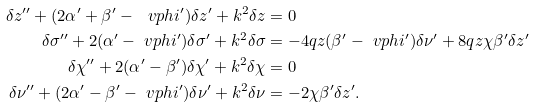Convert formula to latex. <formula><loc_0><loc_0><loc_500><loc_500>\delta z ^ { \prime \prime } + ( 2 \alpha ^ { \prime } + \beta ^ { \prime } - \ v p h i ^ { \prime } ) \delta z ^ { \prime } + k ^ { 2 } \delta z & = 0 \\ \delta \sigma ^ { \prime \prime } + 2 ( \alpha ^ { \prime } - \ v p h i ^ { \prime } ) \delta \sigma ^ { \prime } + k ^ { 2 } \delta \sigma & = - 4 q z ( \beta ^ { \prime } - \ v p h i ^ { \prime } ) \delta \nu ^ { \prime } + 8 q z \chi \beta ^ { \prime } \delta z ^ { \prime } \\ \delta \chi ^ { \prime \prime } + 2 ( \alpha ^ { \prime } - \beta ^ { \prime } ) \delta \chi ^ { \prime } + k ^ { 2 } \delta \chi & = 0 \\ \delta \nu ^ { \prime \prime } + ( 2 \alpha ^ { \prime } - \beta ^ { \prime } - \ v p h i ^ { \prime } ) \delta \nu ^ { \prime } + k ^ { 2 } \delta \nu & = - 2 \chi \beta ^ { \prime } \delta z ^ { \prime } .</formula> 